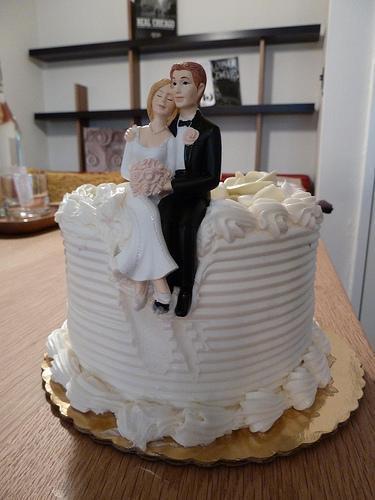How many cakes are on the table?
Give a very brief answer. 1. 